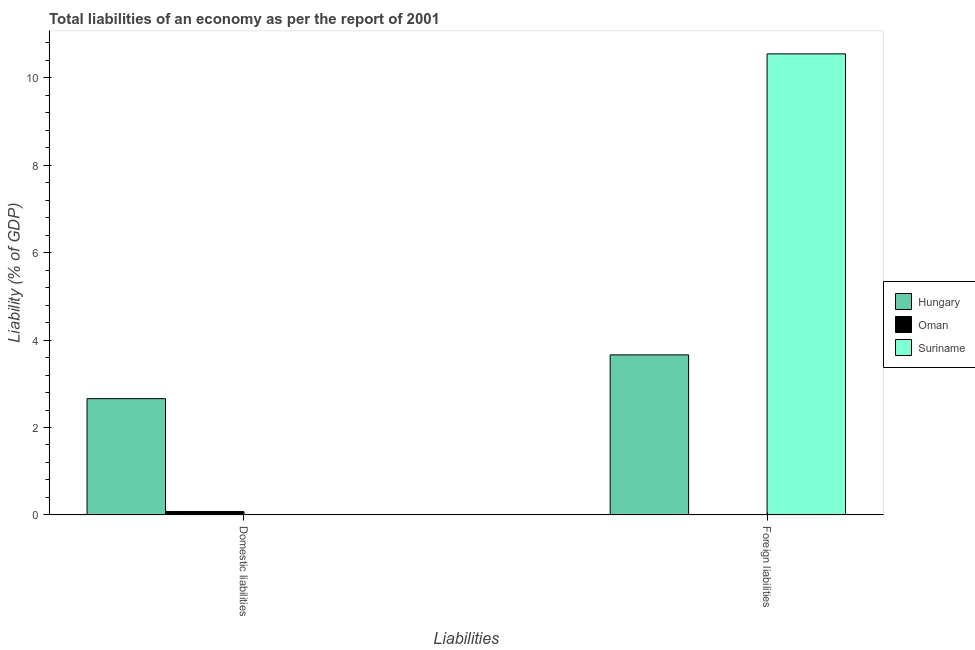How many different coloured bars are there?
Provide a short and direct response. 3. Are the number of bars per tick equal to the number of legend labels?
Keep it short and to the point. No. How many bars are there on the 1st tick from the left?
Make the answer very short. 2. What is the label of the 2nd group of bars from the left?
Give a very brief answer. Foreign liabilities. What is the incurrence of foreign liabilities in Suriname?
Give a very brief answer. 10.55. Across all countries, what is the maximum incurrence of domestic liabilities?
Offer a terse response. 2.66. Across all countries, what is the minimum incurrence of domestic liabilities?
Give a very brief answer. 0. In which country was the incurrence of foreign liabilities maximum?
Keep it short and to the point. Suriname. What is the total incurrence of foreign liabilities in the graph?
Make the answer very short. 14.21. What is the difference between the incurrence of domestic liabilities in Hungary and that in Oman?
Provide a succinct answer. 2.58. What is the difference between the incurrence of foreign liabilities in Oman and the incurrence of domestic liabilities in Hungary?
Make the answer very short. -2.66. What is the average incurrence of foreign liabilities per country?
Provide a short and direct response. 4.74. What is the difference between the incurrence of foreign liabilities and incurrence of domestic liabilities in Hungary?
Offer a terse response. 1. What is the ratio of the incurrence of domestic liabilities in Hungary to that in Oman?
Give a very brief answer. 34.31. In how many countries, is the incurrence of foreign liabilities greater than the average incurrence of foreign liabilities taken over all countries?
Give a very brief answer. 1. How many bars are there?
Keep it short and to the point. 4. Are all the bars in the graph horizontal?
Keep it short and to the point. No. What is the difference between two consecutive major ticks on the Y-axis?
Ensure brevity in your answer.  2. Are the values on the major ticks of Y-axis written in scientific E-notation?
Provide a succinct answer. No. Does the graph contain grids?
Provide a short and direct response. No. Where does the legend appear in the graph?
Give a very brief answer. Center right. How many legend labels are there?
Make the answer very short. 3. How are the legend labels stacked?
Give a very brief answer. Vertical. What is the title of the graph?
Make the answer very short. Total liabilities of an economy as per the report of 2001. Does "Nicaragua" appear as one of the legend labels in the graph?
Make the answer very short. No. What is the label or title of the X-axis?
Ensure brevity in your answer.  Liabilities. What is the label or title of the Y-axis?
Give a very brief answer. Liability (% of GDP). What is the Liability (% of GDP) of Hungary in Domestic liabilities?
Your response must be concise. 2.66. What is the Liability (% of GDP) in Oman in Domestic liabilities?
Your answer should be very brief. 0.08. What is the Liability (% of GDP) of Suriname in Domestic liabilities?
Your answer should be compact. 0. What is the Liability (% of GDP) of Hungary in Foreign liabilities?
Your answer should be compact. 3.66. What is the Liability (% of GDP) in Suriname in Foreign liabilities?
Provide a succinct answer. 10.55. Across all Liabilities, what is the maximum Liability (% of GDP) of Hungary?
Your answer should be compact. 3.66. Across all Liabilities, what is the maximum Liability (% of GDP) of Oman?
Offer a very short reply. 0.08. Across all Liabilities, what is the maximum Liability (% of GDP) of Suriname?
Give a very brief answer. 10.55. Across all Liabilities, what is the minimum Liability (% of GDP) of Hungary?
Provide a succinct answer. 2.66. Across all Liabilities, what is the minimum Liability (% of GDP) in Suriname?
Your response must be concise. 0. What is the total Liability (% of GDP) in Hungary in the graph?
Keep it short and to the point. 6.32. What is the total Liability (% of GDP) of Oman in the graph?
Make the answer very short. 0.08. What is the total Liability (% of GDP) of Suriname in the graph?
Keep it short and to the point. 10.55. What is the difference between the Liability (% of GDP) in Hungary in Domestic liabilities and that in Foreign liabilities?
Provide a succinct answer. -1. What is the difference between the Liability (% of GDP) of Hungary in Domestic liabilities and the Liability (% of GDP) of Suriname in Foreign liabilities?
Your answer should be very brief. -7.89. What is the difference between the Liability (% of GDP) of Oman in Domestic liabilities and the Liability (% of GDP) of Suriname in Foreign liabilities?
Your response must be concise. -10.47. What is the average Liability (% of GDP) of Hungary per Liabilities?
Provide a short and direct response. 3.16. What is the average Liability (% of GDP) in Oman per Liabilities?
Offer a very short reply. 0.04. What is the average Liability (% of GDP) of Suriname per Liabilities?
Provide a succinct answer. 5.27. What is the difference between the Liability (% of GDP) of Hungary and Liability (% of GDP) of Oman in Domestic liabilities?
Your answer should be compact. 2.58. What is the difference between the Liability (% of GDP) in Hungary and Liability (% of GDP) in Suriname in Foreign liabilities?
Give a very brief answer. -6.89. What is the ratio of the Liability (% of GDP) of Hungary in Domestic liabilities to that in Foreign liabilities?
Make the answer very short. 0.73. What is the difference between the highest and the second highest Liability (% of GDP) in Hungary?
Provide a short and direct response. 1. What is the difference between the highest and the lowest Liability (% of GDP) in Oman?
Your answer should be compact. 0.08. What is the difference between the highest and the lowest Liability (% of GDP) of Suriname?
Offer a very short reply. 10.55. 